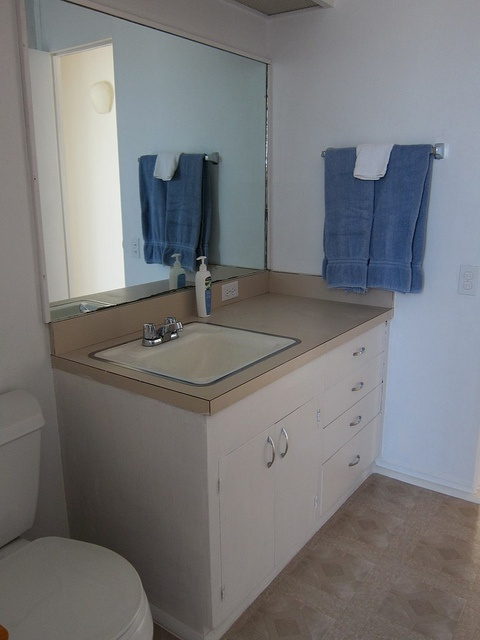Describe the objects in this image and their specific colors. I can see toilet in gray and black tones and sink in gray tones in this image. 